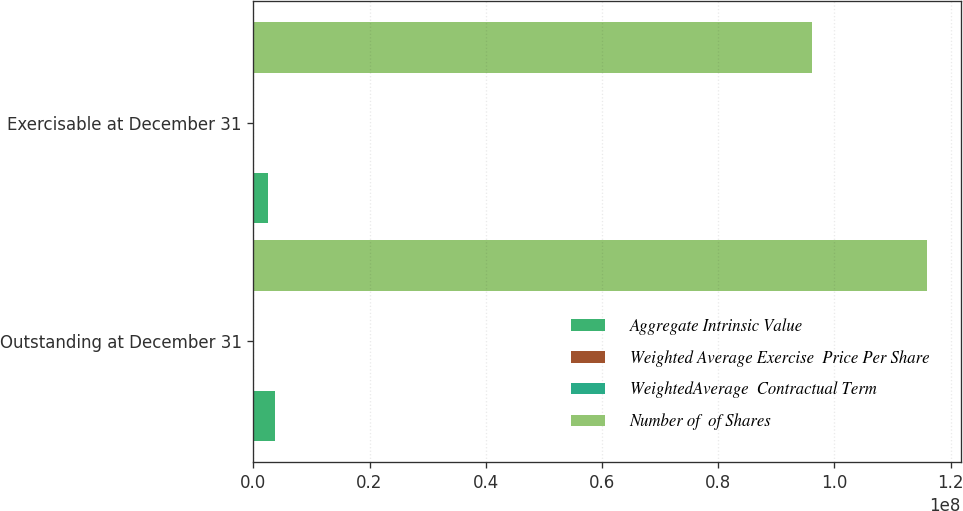Convert chart. <chart><loc_0><loc_0><loc_500><loc_500><stacked_bar_chart><ecel><fcel>Outstanding at December 31<fcel>Exercisable at December 31<nl><fcel>Aggregate Intrinsic Value<fcel>3.656e+06<fcel>2.489e+06<nl><fcel>Weighted Average Exercise  Price Per Share<fcel>30.84<fcel>23.92<nl><fcel>WeightedAverage  Contractual Term<fcel>4.96<fcel>4.54<nl><fcel>Number of  of Shares<fcel>1.15944e+08<fcel>9.6128e+07<nl></chart> 